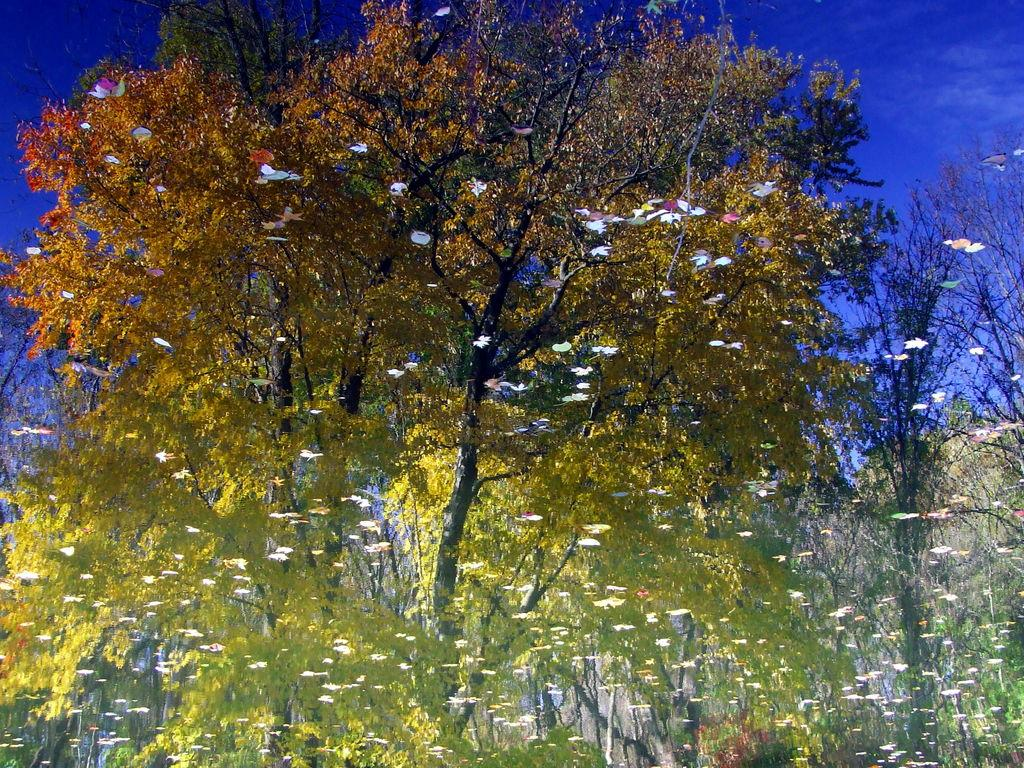What type of artwork is shown in the image? The image appears to be a painting. What is the main subject of the painting? The painting depicts trees. What else is included in the painting besides trees? The painting includes the sky. What type of insurance policy is being discussed in the painting? There is no discussion of insurance policies in the painting; it is a visual representation of trees and the sky. How many ladybugs can be seen on the trees in the painting? There are no ladybugs present in the painting; it only depicts trees and the sky. 